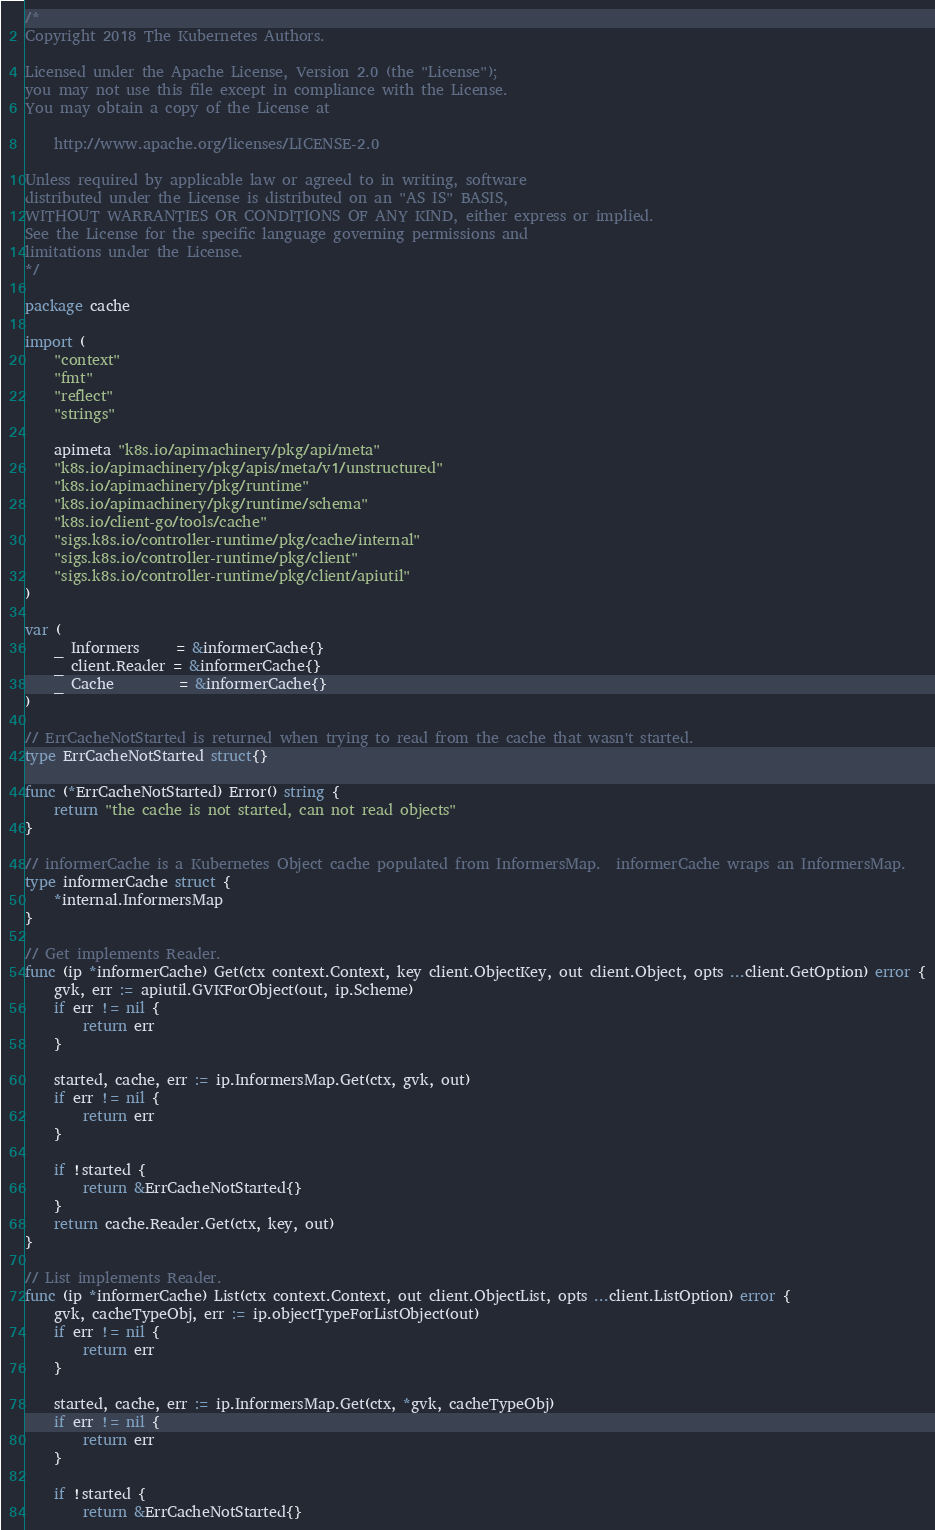Convert code to text. <code><loc_0><loc_0><loc_500><loc_500><_Go_>/*
Copyright 2018 The Kubernetes Authors.

Licensed under the Apache License, Version 2.0 (the "License");
you may not use this file except in compliance with the License.
You may obtain a copy of the License at

    http://www.apache.org/licenses/LICENSE-2.0

Unless required by applicable law or agreed to in writing, software
distributed under the License is distributed on an "AS IS" BASIS,
WITHOUT WARRANTIES OR CONDITIONS OF ANY KIND, either express or implied.
See the License for the specific language governing permissions and
limitations under the License.
*/

package cache

import (
	"context"
	"fmt"
	"reflect"
	"strings"

	apimeta "k8s.io/apimachinery/pkg/api/meta"
	"k8s.io/apimachinery/pkg/apis/meta/v1/unstructured"
	"k8s.io/apimachinery/pkg/runtime"
	"k8s.io/apimachinery/pkg/runtime/schema"
	"k8s.io/client-go/tools/cache"
	"sigs.k8s.io/controller-runtime/pkg/cache/internal"
	"sigs.k8s.io/controller-runtime/pkg/client"
	"sigs.k8s.io/controller-runtime/pkg/client/apiutil"
)

var (
	_ Informers     = &informerCache{}
	_ client.Reader = &informerCache{}
	_ Cache         = &informerCache{}
)

// ErrCacheNotStarted is returned when trying to read from the cache that wasn't started.
type ErrCacheNotStarted struct{}

func (*ErrCacheNotStarted) Error() string {
	return "the cache is not started, can not read objects"
}

// informerCache is a Kubernetes Object cache populated from InformersMap.  informerCache wraps an InformersMap.
type informerCache struct {
	*internal.InformersMap
}

// Get implements Reader.
func (ip *informerCache) Get(ctx context.Context, key client.ObjectKey, out client.Object, opts ...client.GetOption) error {
	gvk, err := apiutil.GVKForObject(out, ip.Scheme)
	if err != nil {
		return err
	}

	started, cache, err := ip.InformersMap.Get(ctx, gvk, out)
	if err != nil {
		return err
	}

	if !started {
		return &ErrCacheNotStarted{}
	}
	return cache.Reader.Get(ctx, key, out)
}

// List implements Reader.
func (ip *informerCache) List(ctx context.Context, out client.ObjectList, opts ...client.ListOption) error {
	gvk, cacheTypeObj, err := ip.objectTypeForListObject(out)
	if err != nil {
		return err
	}

	started, cache, err := ip.InformersMap.Get(ctx, *gvk, cacheTypeObj)
	if err != nil {
		return err
	}

	if !started {
		return &ErrCacheNotStarted{}</code> 